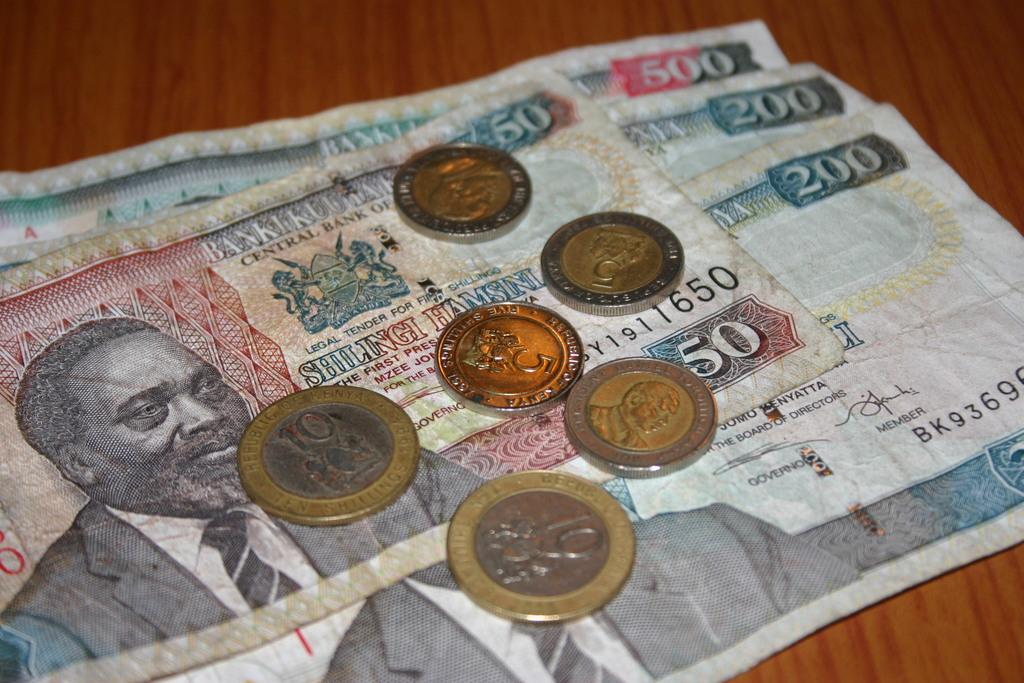How much is the largest bill's denomination?
Keep it short and to the point. 500. What is the smallest bill?
Give a very brief answer. 50. 